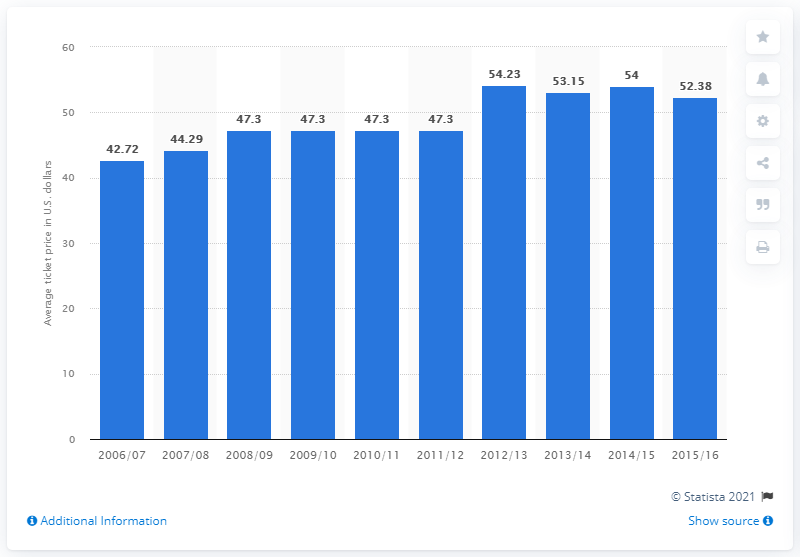Point out several critical features in this image. In the 2006/2007 season, the average ticket price for Denver Nuggets games was 42.72 dollars. 